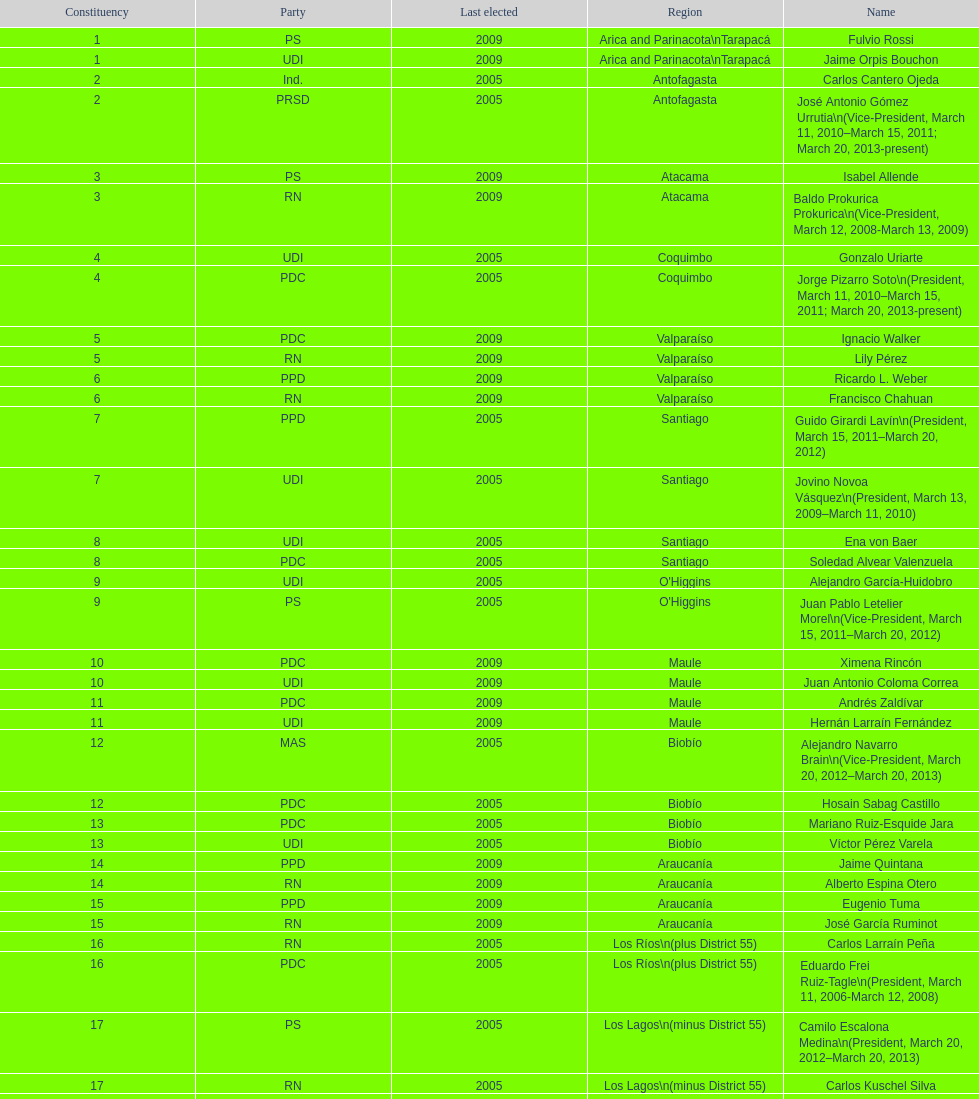Which party did jaime quintana belong to? PPD. 